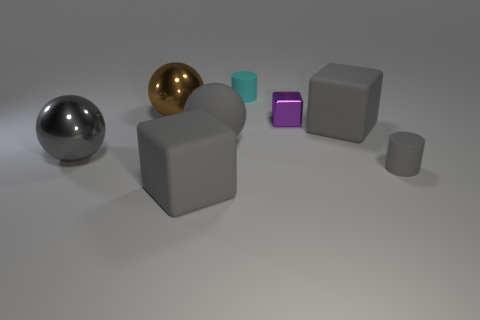Subtract all big gray spheres. How many spheres are left? 1 Subtract all brown balls. How many balls are left? 2 Add 1 tiny things. How many objects exist? 9 Subtract all cylinders. How many objects are left? 6 Subtract 2 cubes. How many cubes are left? 1 Subtract all gray cylinders. Subtract all cyan blocks. How many cylinders are left? 1 Subtract all gray spheres. How many blue blocks are left? 0 Subtract all cyan rubber objects. Subtract all small gray cylinders. How many objects are left? 6 Add 7 small cyan rubber cylinders. How many small cyan rubber cylinders are left? 8 Add 1 big spheres. How many big spheres exist? 4 